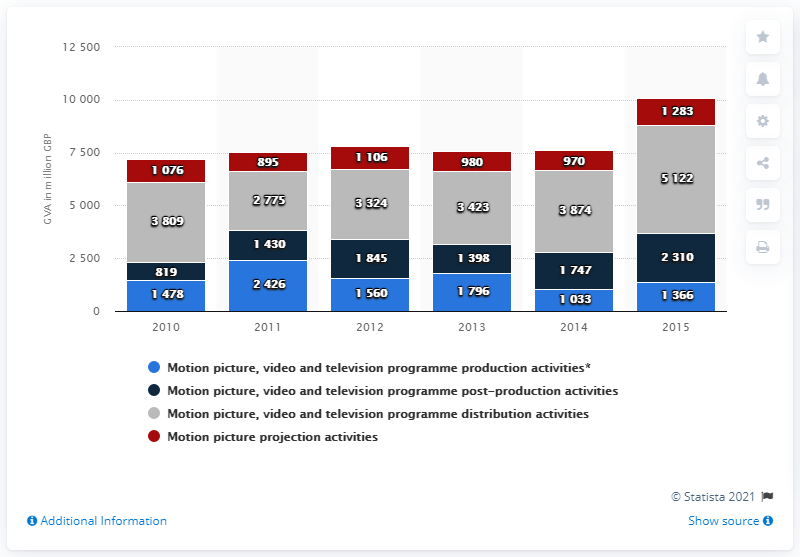Point out several critical features in this image. The gross value added for motion picture, video and television production activities in 2015 was approximately 1,398. 